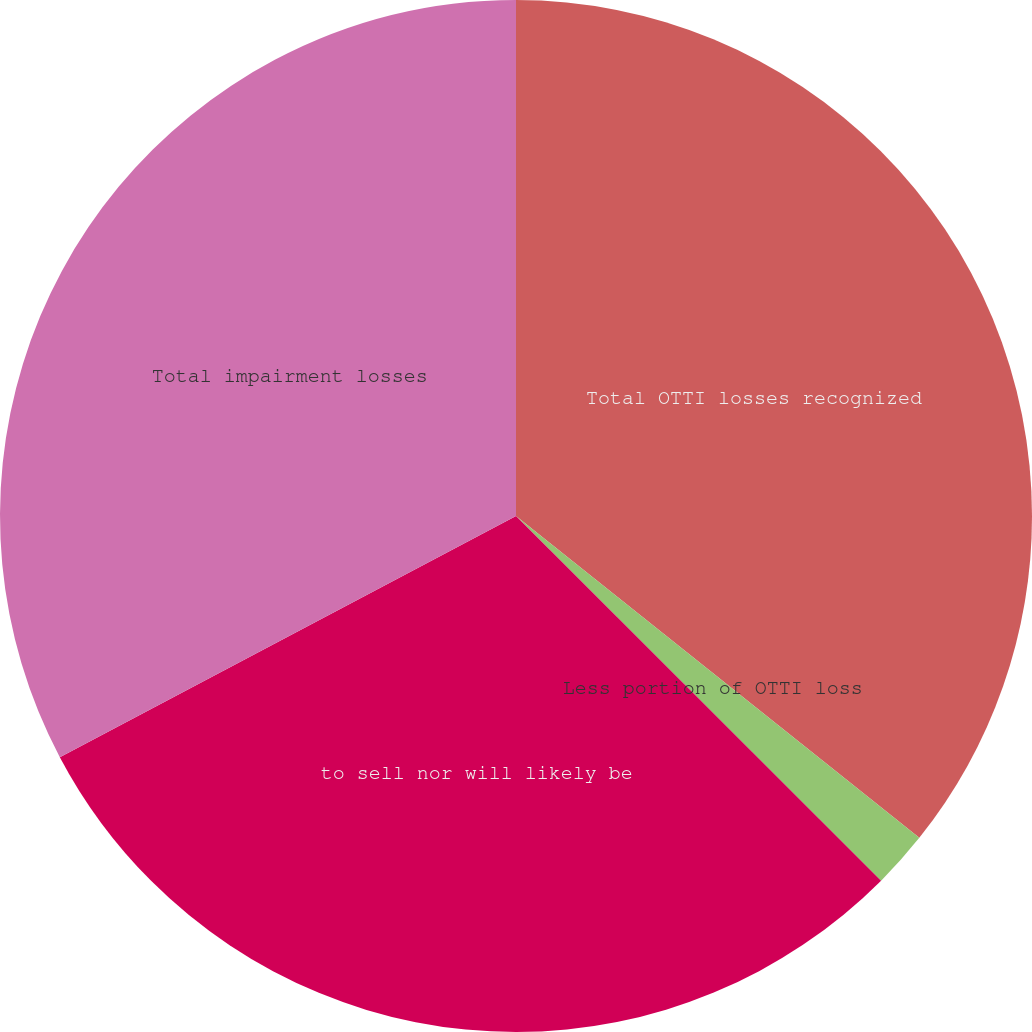Convert chart to OTSL. <chart><loc_0><loc_0><loc_500><loc_500><pie_chart><fcel>Total OTTI losses recognized<fcel>Less portion of OTTI loss<fcel>to sell nor will likely be<fcel>Total impairment losses<nl><fcel>35.72%<fcel>1.77%<fcel>29.77%<fcel>32.74%<nl></chart> 